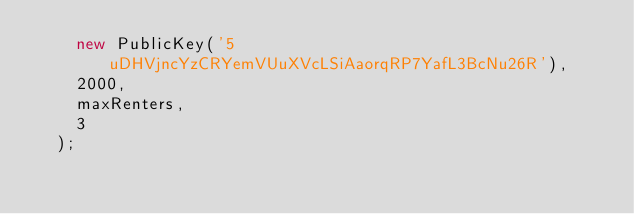<code> <loc_0><loc_0><loc_500><loc_500><_JavaScript_>    new PublicKey('5uDHVjncYzCRYemVUuXVcLSiAaorqRP7YafL3BcNu26R'),
    2000,
    maxRenters,
    3
  );
</code> 